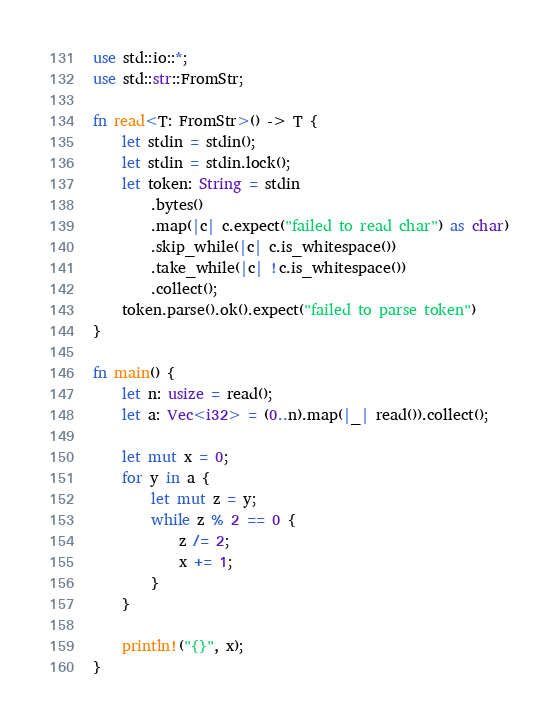Convert code to text. <code><loc_0><loc_0><loc_500><loc_500><_Rust_>use std::io::*;
use std::str::FromStr;

fn read<T: FromStr>() -> T {
    let stdin = stdin();
    let stdin = stdin.lock();
    let token: String = stdin
        .bytes()
        .map(|c| c.expect("failed to read char") as char)
        .skip_while(|c| c.is_whitespace())
        .take_while(|c| !c.is_whitespace())
        .collect();
    token.parse().ok().expect("failed to parse token")
}

fn main() {
    let n: usize = read();
    let a: Vec<i32> = (0..n).map(|_| read()).collect();

    let mut x = 0;
    for y in a {
        let mut z = y;
        while z % 2 == 0 {
            z /= 2;
            x += 1;
        }
    }

    println!("{}", x);
}
</code> 